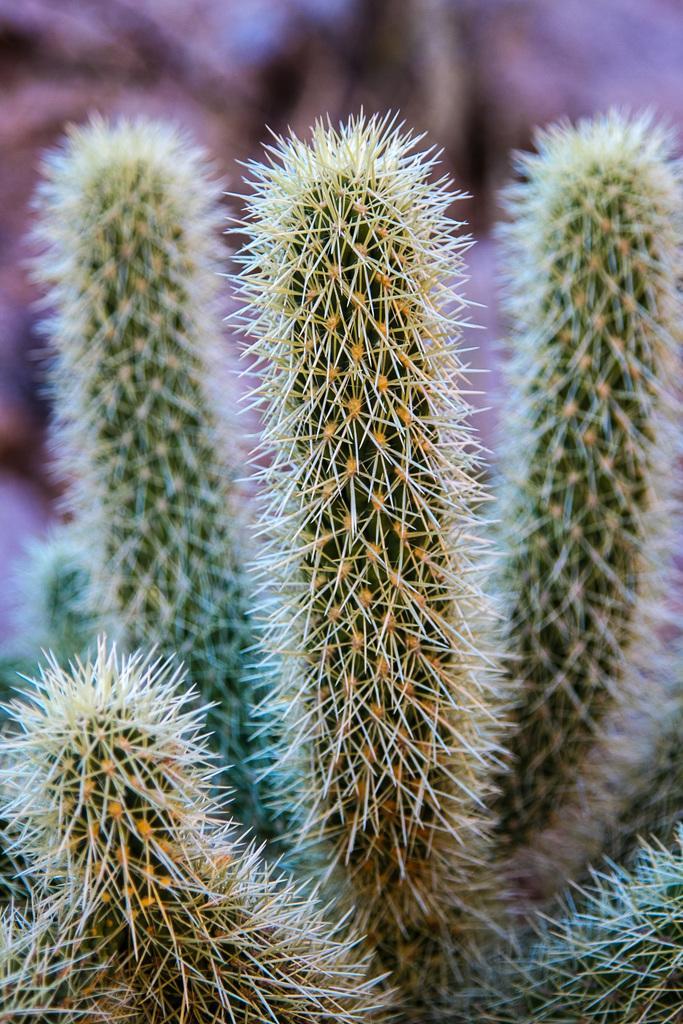Can you describe this image briefly? In the image we can see some plants. Background of the image is blur. 